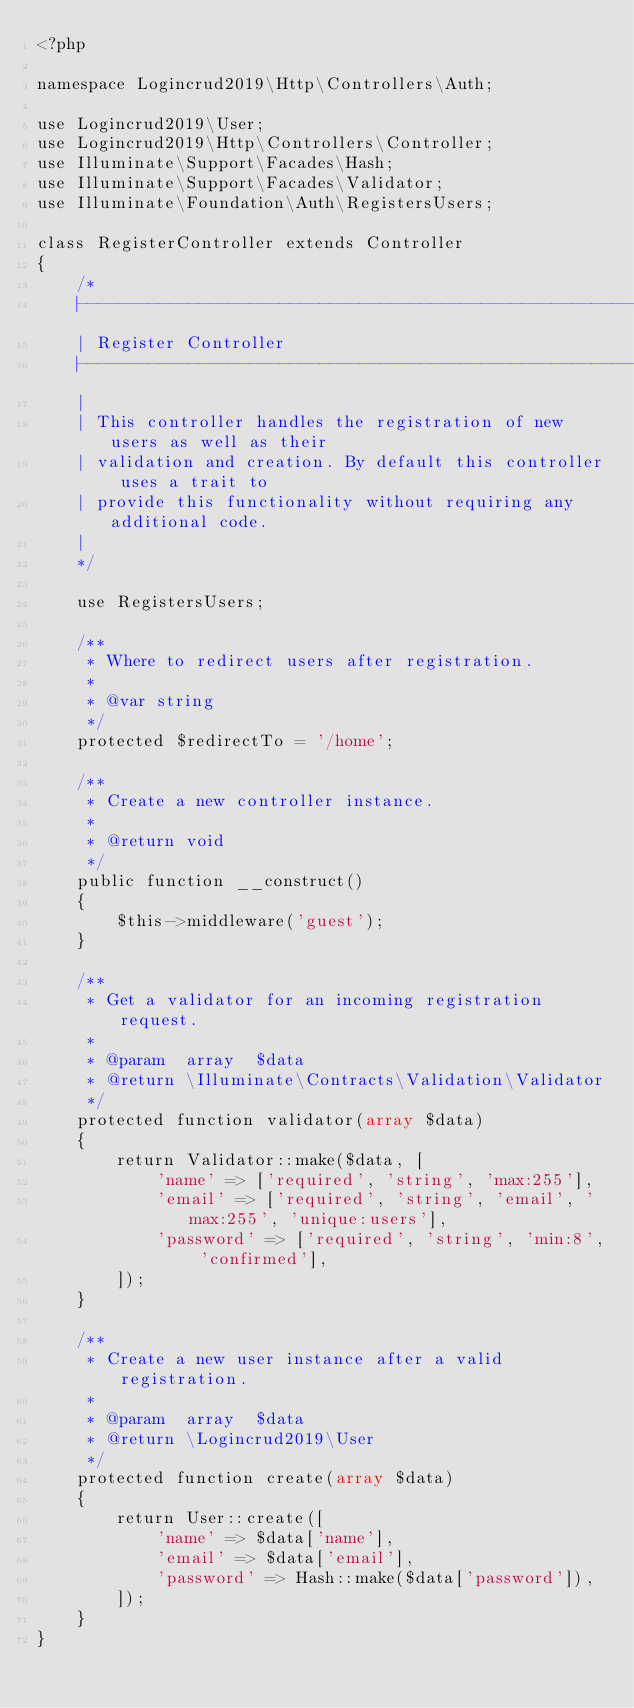<code> <loc_0><loc_0><loc_500><loc_500><_PHP_><?php

namespace Logincrud2019\Http\Controllers\Auth;

use Logincrud2019\User;
use Logincrud2019\Http\Controllers\Controller;
use Illuminate\Support\Facades\Hash;
use Illuminate\Support\Facades\Validator;
use Illuminate\Foundation\Auth\RegistersUsers;

class RegisterController extends Controller
{
    /*
    |--------------------------------------------------------------------------
    | Register Controller
    |--------------------------------------------------------------------------
    |
    | This controller handles the registration of new users as well as their
    | validation and creation. By default this controller uses a trait to
    | provide this functionality without requiring any additional code.
    |
    */

    use RegistersUsers;

    /**
     * Where to redirect users after registration.
     *
     * @var string
     */
    protected $redirectTo = '/home';

    /**
     * Create a new controller instance.
     *
     * @return void
     */
    public function __construct()
    {
        $this->middleware('guest');
    }

    /**
     * Get a validator for an incoming registration request.
     *
     * @param  array  $data
     * @return \Illuminate\Contracts\Validation\Validator
     */
    protected function validator(array $data)
    {
        return Validator::make($data, [
            'name' => ['required', 'string', 'max:255'],
            'email' => ['required', 'string', 'email', 'max:255', 'unique:users'],
            'password' => ['required', 'string', 'min:8', 'confirmed'],
        ]);
    }

    /**
     * Create a new user instance after a valid registration.
     *
     * @param  array  $data
     * @return \Logincrud2019\User
     */
    protected function create(array $data)
    {
        return User::create([
            'name' => $data['name'],
            'email' => $data['email'],
            'password' => Hash::make($data['password']),
        ]);
    }
}
</code> 